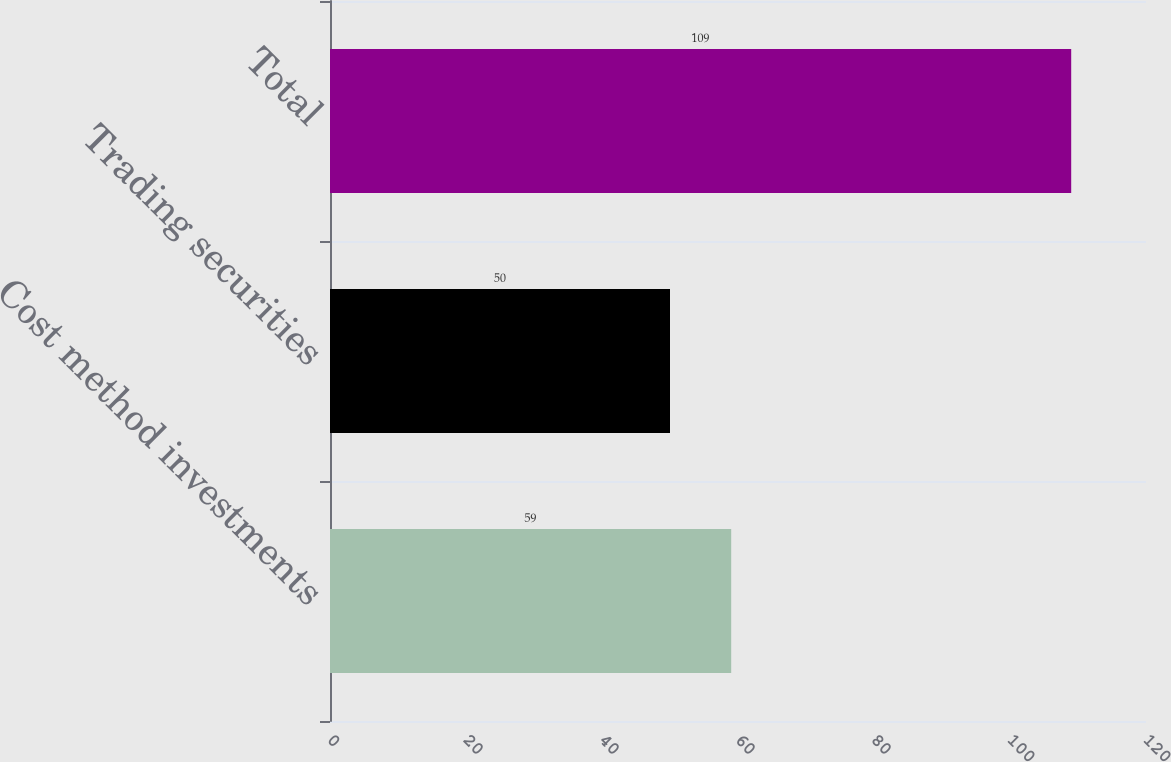Convert chart. <chart><loc_0><loc_0><loc_500><loc_500><bar_chart><fcel>Cost method investments<fcel>Trading securities<fcel>Total<nl><fcel>59<fcel>50<fcel>109<nl></chart> 